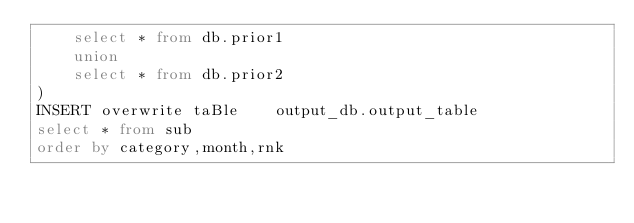Convert code to text. <code><loc_0><loc_0><loc_500><loc_500><_SQL_>    select * from db.prior1
    union 
    select * from db.prior2
)
INSERT overwrite taBle    output_db.output_table    
select * from sub
order by category,month,rnk</code> 